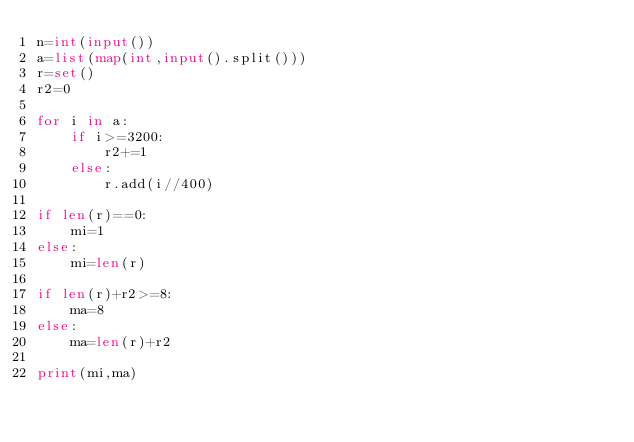<code> <loc_0><loc_0><loc_500><loc_500><_Python_>n=int(input())
a=list(map(int,input().split()))
r=set()
r2=0

for i in a:
    if i>=3200:
        r2+=1
    else:
        r.add(i//400)

if len(r)==0:
    mi=1
else:
    mi=len(r)

if len(r)+r2>=8:
    ma=8
else:
    ma=len(r)+r2

print(mi,ma)</code> 